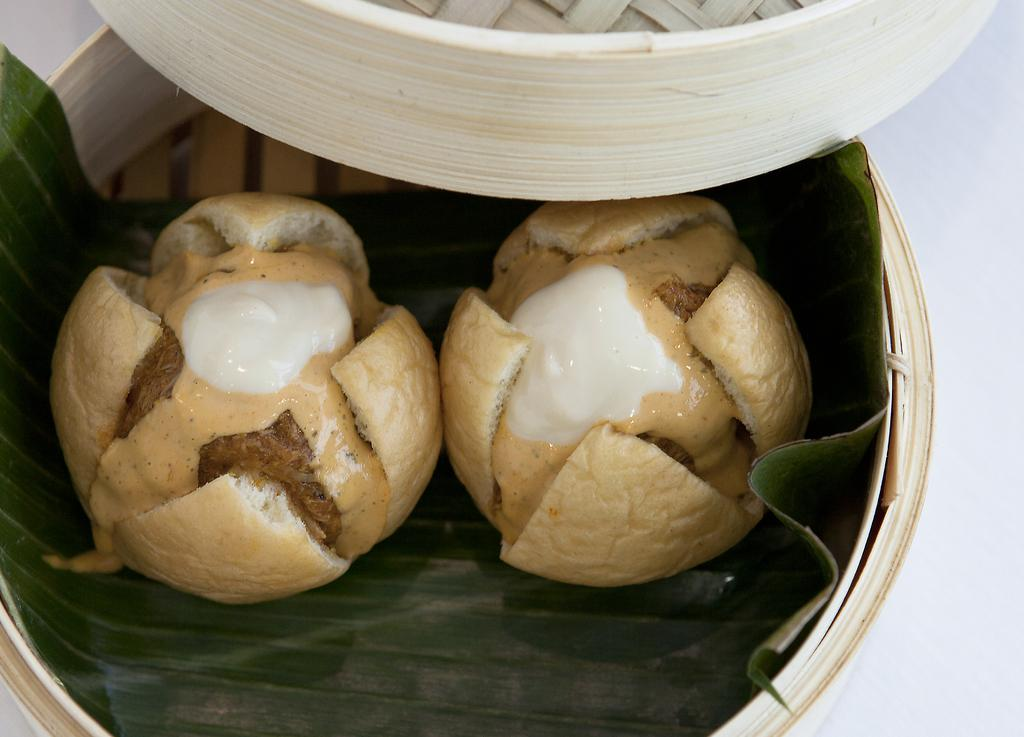What type of food can be seen in the image? There is food in the image, but the specific type is not mentioned. What is the food placed on in the image? The food and banana leaf are in a container. What is the container placed on in the image? The container is placed on a table. How many uncles are sitting at the feast in the image? There is no feast or uncle present in the image. What type of neck accessory is the banana leaf wearing in the image? The banana leaf is not a living being and therefore cannot wear any type of neck accessory. 